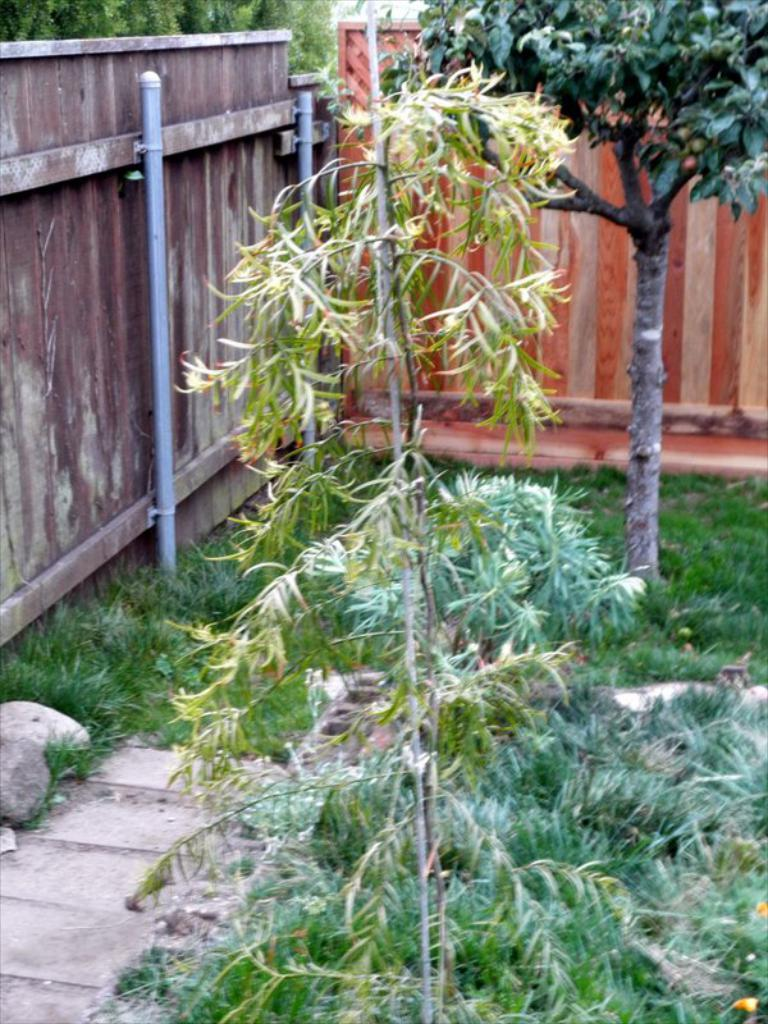What type of vegetation can be seen in the image? There are plants, trees, and grass in the image. What is the ground made of in the image? The ground is made of grass in the image. What is the stone used for in the image? The stone is a part of the landscape in the image. What is the wooden fencing wall used for in the image? The wooden fencing wall is used to enclose or separate areas in the image. What is the purpose of the tubes in the image? The purpose of the tubes in the image is not clear, but they could be part of an irrigation system or for other functional purposes. How many lizards can be seen crawling on the wooden fencing wall in the image? There are no lizards present in the image; it only features plants, trees, grass, a stone, a path, and a wooden fencing wall. 